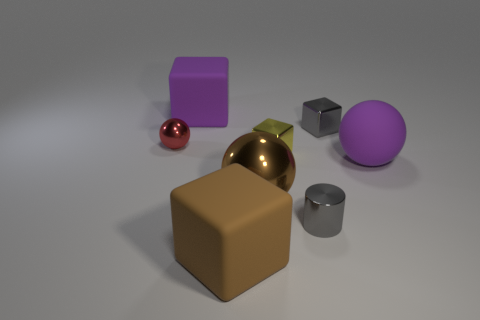Add 1 small cubes. How many objects exist? 9 Subtract all balls. How many objects are left? 5 Add 5 small metallic spheres. How many small metallic spheres are left? 6 Add 2 large purple rubber objects. How many large purple rubber objects exist? 4 Subtract 0 blue cylinders. How many objects are left? 8 Subtract all gray metal cylinders. Subtract all rubber blocks. How many objects are left? 5 